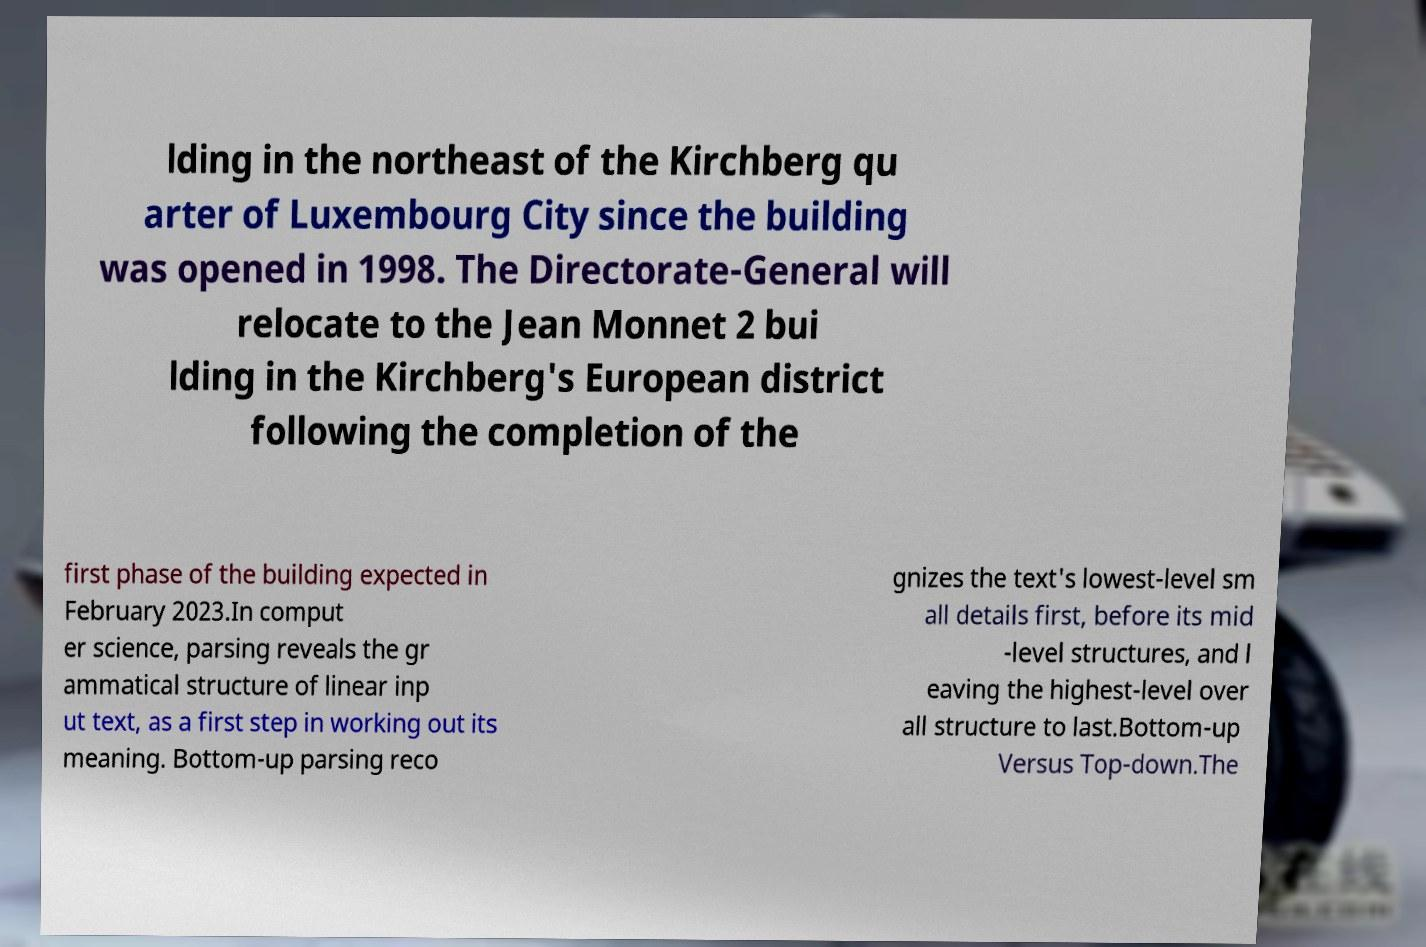I need the written content from this picture converted into text. Can you do that? lding in the northeast of the Kirchberg qu arter of Luxembourg City since the building was opened in 1998. The Directorate-General will relocate to the Jean Monnet 2 bui lding in the Kirchberg's European district following the completion of the first phase of the building expected in February 2023.In comput er science, parsing reveals the gr ammatical structure of linear inp ut text, as a first step in working out its meaning. Bottom-up parsing reco gnizes the text's lowest-level sm all details first, before its mid -level structures, and l eaving the highest-level over all structure to last.Bottom-up Versus Top-down.The 